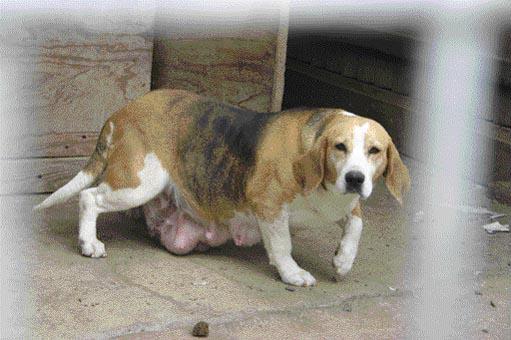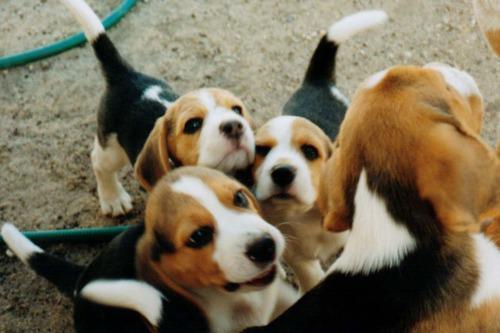The first image is the image on the left, the second image is the image on the right. For the images displayed, is the sentence "A person is on the road with some of the dogs." factually correct? Answer yes or no. No. The first image is the image on the left, the second image is the image on the right. Examine the images to the left and right. Is the description "There is at least one human interacting with a pack of dogs." accurate? Answer yes or no. No. 